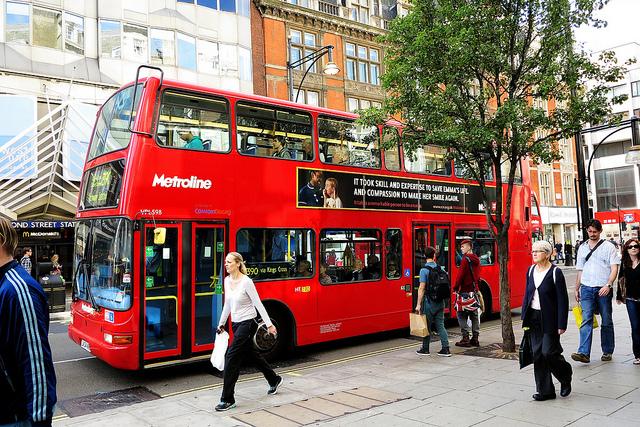What is the word on the side of the bus?
Be succinct. Metroline. What country is most likely photographed here?
Keep it brief. England. How many people do you think fit into this bus?
Keep it brief. 50. 